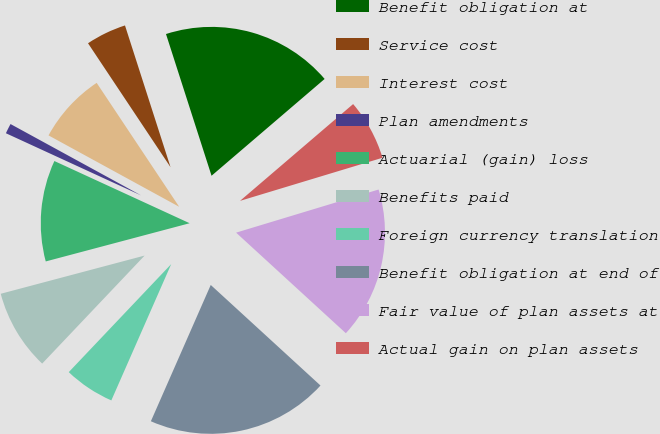Convert chart to OTSL. <chart><loc_0><loc_0><loc_500><loc_500><pie_chart><fcel>Benefit obligation at<fcel>Service cost<fcel>Interest cost<fcel>Plan amendments<fcel>Actuarial (gain) loss<fcel>Benefits paid<fcel>Foreign currency translation<fcel>Benefit obligation at end of<fcel>Fair value of plan assets at<fcel>Actual gain on plan assets<nl><fcel>18.68%<fcel>4.4%<fcel>7.69%<fcel>1.1%<fcel>10.99%<fcel>8.79%<fcel>5.49%<fcel>19.78%<fcel>16.48%<fcel>6.59%<nl></chart> 